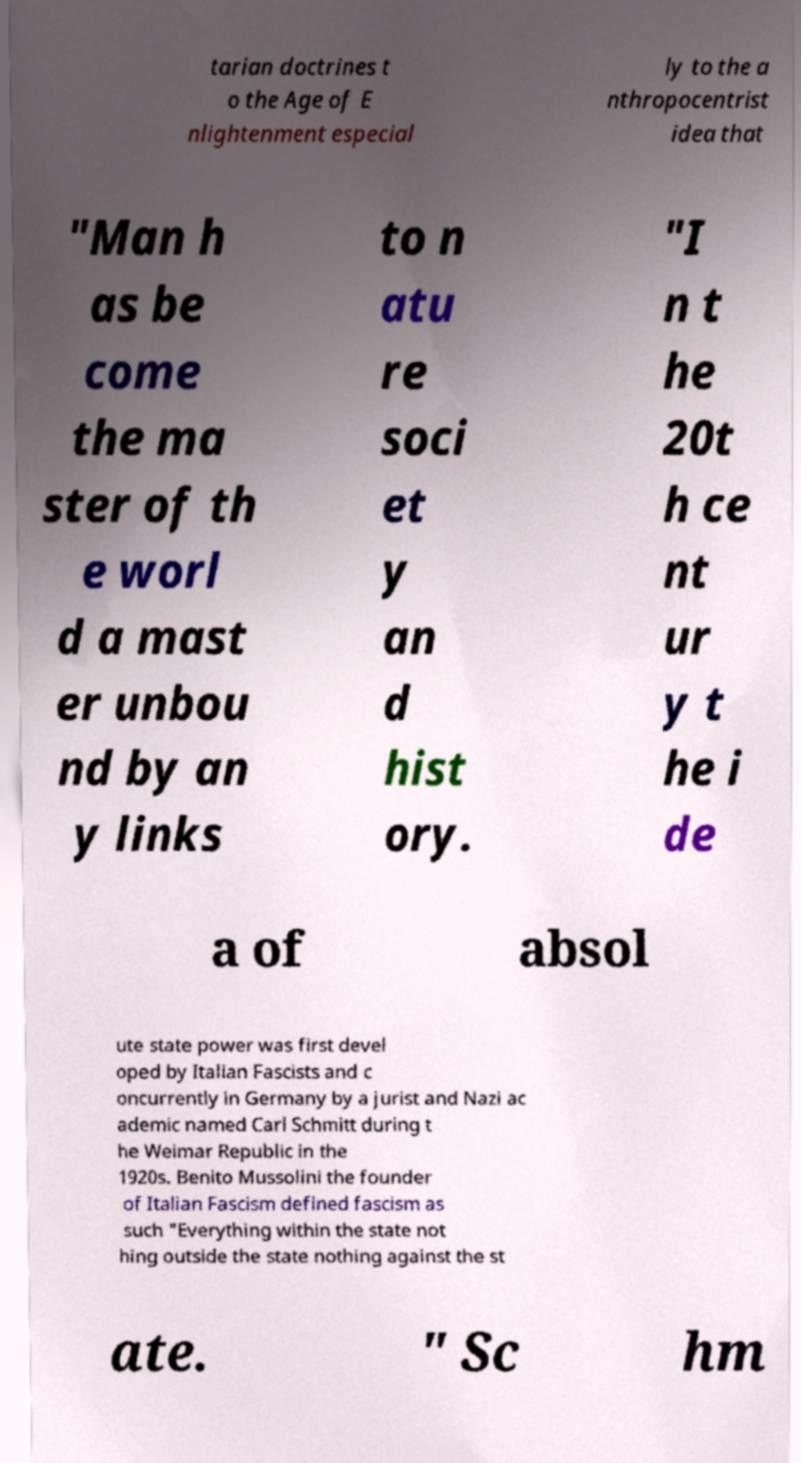For documentation purposes, I need the text within this image transcribed. Could you provide that? tarian doctrines t o the Age of E nlightenment especial ly to the a nthropocentrist idea that "Man h as be come the ma ster of th e worl d a mast er unbou nd by an y links to n atu re soci et y an d hist ory. "I n t he 20t h ce nt ur y t he i de a of absol ute state power was first devel oped by Italian Fascists and c oncurrently in Germany by a jurist and Nazi ac ademic named Carl Schmitt during t he Weimar Republic in the 1920s. Benito Mussolini the founder of Italian Fascism defined fascism as such "Everything within the state not hing outside the state nothing against the st ate. " Sc hm 